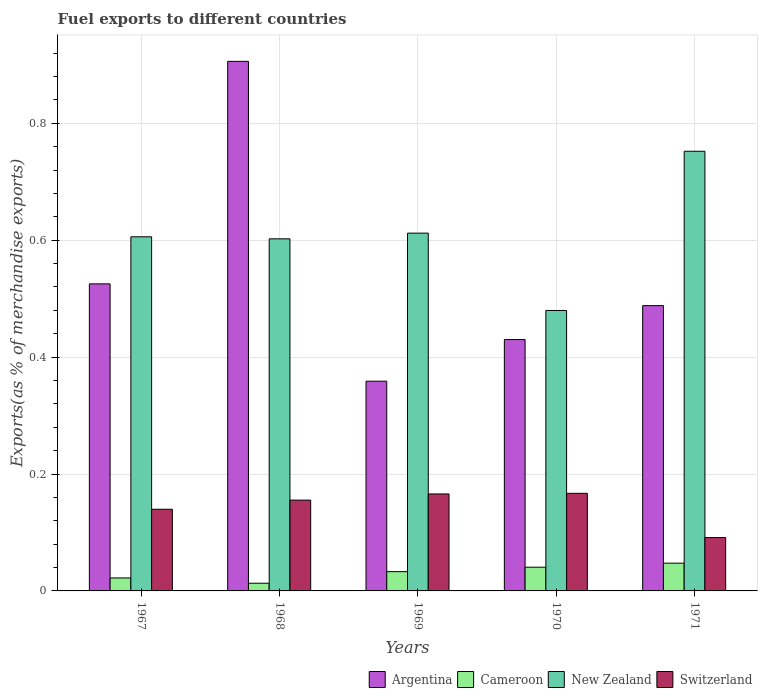How many bars are there on the 1st tick from the left?
Offer a very short reply. 4. What is the label of the 5th group of bars from the left?
Make the answer very short. 1971. What is the percentage of exports to different countries in New Zealand in 1967?
Your response must be concise. 0.61. Across all years, what is the maximum percentage of exports to different countries in Argentina?
Keep it short and to the point. 0.91. Across all years, what is the minimum percentage of exports to different countries in Cameroon?
Offer a very short reply. 0.01. What is the total percentage of exports to different countries in Cameroon in the graph?
Ensure brevity in your answer.  0.16. What is the difference between the percentage of exports to different countries in New Zealand in 1967 and that in 1971?
Offer a terse response. -0.15. What is the difference between the percentage of exports to different countries in Argentina in 1969 and the percentage of exports to different countries in Cameroon in 1970?
Your answer should be compact. 0.32. What is the average percentage of exports to different countries in Switzerland per year?
Offer a terse response. 0.14. In the year 1967, what is the difference between the percentage of exports to different countries in Argentina and percentage of exports to different countries in New Zealand?
Provide a short and direct response. -0.08. What is the ratio of the percentage of exports to different countries in Argentina in 1968 to that in 1971?
Make the answer very short. 1.86. What is the difference between the highest and the second highest percentage of exports to different countries in Switzerland?
Your answer should be compact. 0. What is the difference between the highest and the lowest percentage of exports to different countries in New Zealand?
Give a very brief answer. 0.27. In how many years, is the percentage of exports to different countries in Switzerland greater than the average percentage of exports to different countries in Switzerland taken over all years?
Your response must be concise. 3. Is the sum of the percentage of exports to different countries in Argentina in 1967 and 1968 greater than the maximum percentage of exports to different countries in New Zealand across all years?
Provide a succinct answer. Yes. What does the 2nd bar from the left in 1967 represents?
Give a very brief answer. Cameroon. What does the 2nd bar from the right in 1969 represents?
Your answer should be very brief. New Zealand. Are all the bars in the graph horizontal?
Your answer should be compact. No. What is the difference between two consecutive major ticks on the Y-axis?
Provide a succinct answer. 0.2. Are the values on the major ticks of Y-axis written in scientific E-notation?
Provide a short and direct response. No. Does the graph contain any zero values?
Provide a short and direct response. No. What is the title of the graph?
Your answer should be very brief. Fuel exports to different countries. Does "Cambodia" appear as one of the legend labels in the graph?
Ensure brevity in your answer.  No. What is the label or title of the Y-axis?
Offer a terse response. Exports(as % of merchandise exports). What is the Exports(as % of merchandise exports) of Argentina in 1967?
Offer a terse response. 0.53. What is the Exports(as % of merchandise exports) of Cameroon in 1967?
Provide a succinct answer. 0.02. What is the Exports(as % of merchandise exports) of New Zealand in 1967?
Your response must be concise. 0.61. What is the Exports(as % of merchandise exports) in Switzerland in 1967?
Give a very brief answer. 0.14. What is the Exports(as % of merchandise exports) in Argentina in 1968?
Keep it short and to the point. 0.91. What is the Exports(as % of merchandise exports) of Cameroon in 1968?
Provide a short and direct response. 0.01. What is the Exports(as % of merchandise exports) of New Zealand in 1968?
Your answer should be compact. 0.6. What is the Exports(as % of merchandise exports) in Switzerland in 1968?
Your answer should be very brief. 0.16. What is the Exports(as % of merchandise exports) of Argentina in 1969?
Provide a short and direct response. 0.36. What is the Exports(as % of merchandise exports) of Cameroon in 1969?
Give a very brief answer. 0.03. What is the Exports(as % of merchandise exports) of New Zealand in 1969?
Offer a terse response. 0.61. What is the Exports(as % of merchandise exports) in Switzerland in 1969?
Offer a very short reply. 0.17. What is the Exports(as % of merchandise exports) in Argentina in 1970?
Your answer should be very brief. 0.43. What is the Exports(as % of merchandise exports) in Cameroon in 1970?
Your response must be concise. 0.04. What is the Exports(as % of merchandise exports) in New Zealand in 1970?
Keep it short and to the point. 0.48. What is the Exports(as % of merchandise exports) in Switzerland in 1970?
Provide a succinct answer. 0.17. What is the Exports(as % of merchandise exports) of Argentina in 1971?
Make the answer very short. 0.49. What is the Exports(as % of merchandise exports) in Cameroon in 1971?
Make the answer very short. 0.05. What is the Exports(as % of merchandise exports) in New Zealand in 1971?
Make the answer very short. 0.75. What is the Exports(as % of merchandise exports) of Switzerland in 1971?
Your answer should be compact. 0.09. Across all years, what is the maximum Exports(as % of merchandise exports) of Argentina?
Keep it short and to the point. 0.91. Across all years, what is the maximum Exports(as % of merchandise exports) in Cameroon?
Your answer should be very brief. 0.05. Across all years, what is the maximum Exports(as % of merchandise exports) of New Zealand?
Offer a terse response. 0.75. Across all years, what is the maximum Exports(as % of merchandise exports) in Switzerland?
Your response must be concise. 0.17. Across all years, what is the minimum Exports(as % of merchandise exports) in Argentina?
Ensure brevity in your answer.  0.36. Across all years, what is the minimum Exports(as % of merchandise exports) of Cameroon?
Offer a terse response. 0.01. Across all years, what is the minimum Exports(as % of merchandise exports) in New Zealand?
Offer a terse response. 0.48. Across all years, what is the minimum Exports(as % of merchandise exports) of Switzerland?
Keep it short and to the point. 0.09. What is the total Exports(as % of merchandise exports) in Argentina in the graph?
Your answer should be very brief. 2.71. What is the total Exports(as % of merchandise exports) in Cameroon in the graph?
Offer a very short reply. 0.16. What is the total Exports(as % of merchandise exports) in New Zealand in the graph?
Make the answer very short. 3.05. What is the total Exports(as % of merchandise exports) of Switzerland in the graph?
Offer a terse response. 0.72. What is the difference between the Exports(as % of merchandise exports) of Argentina in 1967 and that in 1968?
Give a very brief answer. -0.38. What is the difference between the Exports(as % of merchandise exports) in Cameroon in 1967 and that in 1968?
Your answer should be compact. 0.01. What is the difference between the Exports(as % of merchandise exports) of New Zealand in 1967 and that in 1968?
Your answer should be very brief. 0. What is the difference between the Exports(as % of merchandise exports) of Switzerland in 1967 and that in 1968?
Offer a very short reply. -0.02. What is the difference between the Exports(as % of merchandise exports) in Argentina in 1967 and that in 1969?
Make the answer very short. 0.17. What is the difference between the Exports(as % of merchandise exports) of Cameroon in 1967 and that in 1969?
Offer a very short reply. -0.01. What is the difference between the Exports(as % of merchandise exports) of New Zealand in 1967 and that in 1969?
Give a very brief answer. -0.01. What is the difference between the Exports(as % of merchandise exports) of Switzerland in 1967 and that in 1969?
Give a very brief answer. -0.03. What is the difference between the Exports(as % of merchandise exports) of Argentina in 1967 and that in 1970?
Provide a short and direct response. 0.1. What is the difference between the Exports(as % of merchandise exports) in Cameroon in 1967 and that in 1970?
Keep it short and to the point. -0.02. What is the difference between the Exports(as % of merchandise exports) in New Zealand in 1967 and that in 1970?
Offer a very short reply. 0.13. What is the difference between the Exports(as % of merchandise exports) of Switzerland in 1967 and that in 1970?
Give a very brief answer. -0.03. What is the difference between the Exports(as % of merchandise exports) in Argentina in 1967 and that in 1971?
Your answer should be very brief. 0.04. What is the difference between the Exports(as % of merchandise exports) in Cameroon in 1967 and that in 1971?
Make the answer very short. -0.03. What is the difference between the Exports(as % of merchandise exports) in New Zealand in 1967 and that in 1971?
Your response must be concise. -0.15. What is the difference between the Exports(as % of merchandise exports) of Switzerland in 1967 and that in 1971?
Offer a terse response. 0.05. What is the difference between the Exports(as % of merchandise exports) in Argentina in 1968 and that in 1969?
Your answer should be compact. 0.55. What is the difference between the Exports(as % of merchandise exports) in Cameroon in 1968 and that in 1969?
Your response must be concise. -0.02. What is the difference between the Exports(as % of merchandise exports) in New Zealand in 1968 and that in 1969?
Give a very brief answer. -0.01. What is the difference between the Exports(as % of merchandise exports) of Switzerland in 1968 and that in 1969?
Give a very brief answer. -0.01. What is the difference between the Exports(as % of merchandise exports) of Argentina in 1968 and that in 1970?
Keep it short and to the point. 0.48. What is the difference between the Exports(as % of merchandise exports) in Cameroon in 1968 and that in 1970?
Keep it short and to the point. -0.03. What is the difference between the Exports(as % of merchandise exports) in New Zealand in 1968 and that in 1970?
Provide a succinct answer. 0.12. What is the difference between the Exports(as % of merchandise exports) of Switzerland in 1968 and that in 1970?
Give a very brief answer. -0.01. What is the difference between the Exports(as % of merchandise exports) of Argentina in 1968 and that in 1971?
Your answer should be compact. 0.42. What is the difference between the Exports(as % of merchandise exports) of Cameroon in 1968 and that in 1971?
Keep it short and to the point. -0.03. What is the difference between the Exports(as % of merchandise exports) in New Zealand in 1968 and that in 1971?
Keep it short and to the point. -0.15. What is the difference between the Exports(as % of merchandise exports) of Switzerland in 1968 and that in 1971?
Your answer should be compact. 0.06. What is the difference between the Exports(as % of merchandise exports) of Argentina in 1969 and that in 1970?
Make the answer very short. -0.07. What is the difference between the Exports(as % of merchandise exports) of Cameroon in 1969 and that in 1970?
Your answer should be very brief. -0.01. What is the difference between the Exports(as % of merchandise exports) of New Zealand in 1969 and that in 1970?
Give a very brief answer. 0.13. What is the difference between the Exports(as % of merchandise exports) of Switzerland in 1969 and that in 1970?
Your response must be concise. -0. What is the difference between the Exports(as % of merchandise exports) in Argentina in 1969 and that in 1971?
Your answer should be compact. -0.13. What is the difference between the Exports(as % of merchandise exports) in Cameroon in 1969 and that in 1971?
Ensure brevity in your answer.  -0.01. What is the difference between the Exports(as % of merchandise exports) of New Zealand in 1969 and that in 1971?
Your answer should be compact. -0.14. What is the difference between the Exports(as % of merchandise exports) in Switzerland in 1969 and that in 1971?
Your answer should be compact. 0.07. What is the difference between the Exports(as % of merchandise exports) in Argentina in 1970 and that in 1971?
Give a very brief answer. -0.06. What is the difference between the Exports(as % of merchandise exports) in Cameroon in 1970 and that in 1971?
Your answer should be compact. -0.01. What is the difference between the Exports(as % of merchandise exports) in New Zealand in 1970 and that in 1971?
Your answer should be very brief. -0.27. What is the difference between the Exports(as % of merchandise exports) of Switzerland in 1970 and that in 1971?
Make the answer very short. 0.08. What is the difference between the Exports(as % of merchandise exports) in Argentina in 1967 and the Exports(as % of merchandise exports) in Cameroon in 1968?
Offer a very short reply. 0.51. What is the difference between the Exports(as % of merchandise exports) of Argentina in 1967 and the Exports(as % of merchandise exports) of New Zealand in 1968?
Make the answer very short. -0.08. What is the difference between the Exports(as % of merchandise exports) in Argentina in 1967 and the Exports(as % of merchandise exports) in Switzerland in 1968?
Make the answer very short. 0.37. What is the difference between the Exports(as % of merchandise exports) in Cameroon in 1967 and the Exports(as % of merchandise exports) in New Zealand in 1968?
Your answer should be compact. -0.58. What is the difference between the Exports(as % of merchandise exports) in Cameroon in 1967 and the Exports(as % of merchandise exports) in Switzerland in 1968?
Ensure brevity in your answer.  -0.13. What is the difference between the Exports(as % of merchandise exports) in New Zealand in 1967 and the Exports(as % of merchandise exports) in Switzerland in 1968?
Keep it short and to the point. 0.45. What is the difference between the Exports(as % of merchandise exports) in Argentina in 1967 and the Exports(as % of merchandise exports) in Cameroon in 1969?
Your answer should be compact. 0.49. What is the difference between the Exports(as % of merchandise exports) of Argentina in 1967 and the Exports(as % of merchandise exports) of New Zealand in 1969?
Keep it short and to the point. -0.09. What is the difference between the Exports(as % of merchandise exports) in Argentina in 1967 and the Exports(as % of merchandise exports) in Switzerland in 1969?
Provide a short and direct response. 0.36. What is the difference between the Exports(as % of merchandise exports) of Cameroon in 1967 and the Exports(as % of merchandise exports) of New Zealand in 1969?
Keep it short and to the point. -0.59. What is the difference between the Exports(as % of merchandise exports) of Cameroon in 1967 and the Exports(as % of merchandise exports) of Switzerland in 1969?
Offer a very short reply. -0.14. What is the difference between the Exports(as % of merchandise exports) of New Zealand in 1967 and the Exports(as % of merchandise exports) of Switzerland in 1969?
Provide a succinct answer. 0.44. What is the difference between the Exports(as % of merchandise exports) of Argentina in 1967 and the Exports(as % of merchandise exports) of Cameroon in 1970?
Your answer should be compact. 0.48. What is the difference between the Exports(as % of merchandise exports) of Argentina in 1967 and the Exports(as % of merchandise exports) of New Zealand in 1970?
Provide a succinct answer. 0.05. What is the difference between the Exports(as % of merchandise exports) in Argentina in 1967 and the Exports(as % of merchandise exports) in Switzerland in 1970?
Make the answer very short. 0.36. What is the difference between the Exports(as % of merchandise exports) in Cameroon in 1967 and the Exports(as % of merchandise exports) in New Zealand in 1970?
Provide a succinct answer. -0.46. What is the difference between the Exports(as % of merchandise exports) in Cameroon in 1967 and the Exports(as % of merchandise exports) in Switzerland in 1970?
Your answer should be compact. -0.14. What is the difference between the Exports(as % of merchandise exports) in New Zealand in 1967 and the Exports(as % of merchandise exports) in Switzerland in 1970?
Your response must be concise. 0.44. What is the difference between the Exports(as % of merchandise exports) of Argentina in 1967 and the Exports(as % of merchandise exports) of Cameroon in 1971?
Make the answer very short. 0.48. What is the difference between the Exports(as % of merchandise exports) in Argentina in 1967 and the Exports(as % of merchandise exports) in New Zealand in 1971?
Your response must be concise. -0.23. What is the difference between the Exports(as % of merchandise exports) of Argentina in 1967 and the Exports(as % of merchandise exports) of Switzerland in 1971?
Offer a terse response. 0.43. What is the difference between the Exports(as % of merchandise exports) of Cameroon in 1967 and the Exports(as % of merchandise exports) of New Zealand in 1971?
Give a very brief answer. -0.73. What is the difference between the Exports(as % of merchandise exports) of Cameroon in 1967 and the Exports(as % of merchandise exports) of Switzerland in 1971?
Make the answer very short. -0.07. What is the difference between the Exports(as % of merchandise exports) in New Zealand in 1967 and the Exports(as % of merchandise exports) in Switzerland in 1971?
Keep it short and to the point. 0.51. What is the difference between the Exports(as % of merchandise exports) in Argentina in 1968 and the Exports(as % of merchandise exports) in Cameroon in 1969?
Give a very brief answer. 0.87. What is the difference between the Exports(as % of merchandise exports) of Argentina in 1968 and the Exports(as % of merchandise exports) of New Zealand in 1969?
Keep it short and to the point. 0.29. What is the difference between the Exports(as % of merchandise exports) in Argentina in 1968 and the Exports(as % of merchandise exports) in Switzerland in 1969?
Your answer should be very brief. 0.74. What is the difference between the Exports(as % of merchandise exports) of Cameroon in 1968 and the Exports(as % of merchandise exports) of New Zealand in 1969?
Your response must be concise. -0.6. What is the difference between the Exports(as % of merchandise exports) of Cameroon in 1968 and the Exports(as % of merchandise exports) of Switzerland in 1969?
Your answer should be very brief. -0.15. What is the difference between the Exports(as % of merchandise exports) in New Zealand in 1968 and the Exports(as % of merchandise exports) in Switzerland in 1969?
Provide a succinct answer. 0.44. What is the difference between the Exports(as % of merchandise exports) in Argentina in 1968 and the Exports(as % of merchandise exports) in Cameroon in 1970?
Provide a short and direct response. 0.87. What is the difference between the Exports(as % of merchandise exports) in Argentina in 1968 and the Exports(as % of merchandise exports) in New Zealand in 1970?
Offer a very short reply. 0.43. What is the difference between the Exports(as % of merchandise exports) in Argentina in 1968 and the Exports(as % of merchandise exports) in Switzerland in 1970?
Ensure brevity in your answer.  0.74. What is the difference between the Exports(as % of merchandise exports) in Cameroon in 1968 and the Exports(as % of merchandise exports) in New Zealand in 1970?
Keep it short and to the point. -0.47. What is the difference between the Exports(as % of merchandise exports) of Cameroon in 1968 and the Exports(as % of merchandise exports) of Switzerland in 1970?
Keep it short and to the point. -0.15. What is the difference between the Exports(as % of merchandise exports) of New Zealand in 1968 and the Exports(as % of merchandise exports) of Switzerland in 1970?
Provide a short and direct response. 0.44. What is the difference between the Exports(as % of merchandise exports) in Argentina in 1968 and the Exports(as % of merchandise exports) in Cameroon in 1971?
Provide a short and direct response. 0.86. What is the difference between the Exports(as % of merchandise exports) of Argentina in 1968 and the Exports(as % of merchandise exports) of New Zealand in 1971?
Your response must be concise. 0.15. What is the difference between the Exports(as % of merchandise exports) in Argentina in 1968 and the Exports(as % of merchandise exports) in Switzerland in 1971?
Your answer should be very brief. 0.81. What is the difference between the Exports(as % of merchandise exports) in Cameroon in 1968 and the Exports(as % of merchandise exports) in New Zealand in 1971?
Offer a terse response. -0.74. What is the difference between the Exports(as % of merchandise exports) in Cameroon in 1968 and the Exports(as % of merchandise exports) in Switzerland in 1971?
Your answer should be very brief. -0.08. What is the difference between the Exports(as % of merchandise exports) in New Zealand in 1968 and the Exports(as % of merchandise exports) in Switzerland in 1971?
Give a very brief answer. 0.51. What is the difference between the Exports(as % of merchandise exports) in Argentina in 1969 and the Exports(as % of merchandise exports) in Cameroon in 1970?
Ensure brevity in your answer.  0.32. What is the difference between the Exports(as % of merchandise exports) of Argentina in 1969 and the Exports(as % of merchandise exports) of New Zealand in 1970?
Make the answer very short. -0.12. What is the difference between the Exports(as % of merchandise exports) of Argentina in 1969 and the Exports(as % of merchandise exports) of Switzerland in 1970?
Offer a terse response. 0.19. What is the difference between the Exports(as % of merchandise exports) in Cameroon in 1969 and the Exports(as % of merchandise exports) in New Zealand in 1970?
Your answer should be very brief. -0.45. What is the difference between the Exports(as % of merchandise exports) in Cameroon in 1969 and the Exports(as % of merchandise exports) in Switzerland in 1970?
Offer a very short reply. -0.13. What is the difference between the Exports(as % of merchandise exports) in New Zealand in 1969 and the Exports(as % of merchandise exports) in Switzerland in 1970?
Keep it short and to the point. 0.45. What is the difference between the Exports(as % of merchandise exports) in Argentina in 1969 and the Exports(as % of merchandise exports) in Cameroon in 1971?
Ensure brevity in your answer.  0.31. What is the difference between the Exports(as % of merchandise exports) in Argentina in 1969 and the Exports(as % of merchandise exports) in New Zealand in 1971?
Provide a short and direct response. -0.39. What is the difference between the Exports(as % of merchandise exports) of Argentina in 1969 and the Exports(as % of merchandise exports) of Switzerland in 1971?
Make the answer very short. 0.27. What is the difference between the Exports(as % of merchandise exports) of Cameroon in 1969 and the Exports(as % of merchandise exports) of New Zealand in 1971?
Provide a short and direct response. -0.72. What is the difference between the Exports(as % of merchandise exports) in Cameroon in 1969 and the Exports(as % of merchandise exports) in Switzerland in 1971?
Offer a terse response. -0.06. What is the difference between the Exports(as % of merchandise exports) in New Zealand in 1969 and the Exports(as % of merchandise exports) in Switzerland in 1971?
Offer a terse response. 0.52. What is the difference between the Exports(as % of merchandise exports) in Argentina in 1970 and the Exports(as % of merchandise exports) in Cameroon in 1971?
Provide a succinct answer. 0.38. What is the difference between the Exports(as % of merchandise exports) in Argentina in 1970 and the Exports(as % of merchandise exports) in New Zealand in 1971?
Your answer should be very brief. -0.32. What is the difference between the Exports(as % of merchandise exports) in Argentina in 1970 and the Exports(as % of merchandise exports) in Switzerland in 1971?
Your answer should be compact. 0.34. What is the difference between the Exports(as % of merchandise exports) of Cameroon in 1970 and the Exports(as % of merchandise exports) of New Zealand in 1971?
Give a very brief answer. -0.71. What is the difference between the Exports(as % of merchandise exports) in Cameroon in 1970 and the Exports(as % of merchandise exports) in Switzerland in 1971?
Keep it short and to the point. -0.05. What is the difference between the Exports(as % of merchandise exports) in New Zealand in 1970 and the Exports(as % of merchandise exports) in Switzerland in 1971?
Ensure brevity in your answer.  0.39. What is the average Exports(as % of merchandise exports) in Argentina per year?
Offer a terse response. 0.54. What is the average Exports(as % of merchandise exports) of Cameroon per year?
Provide a succinct answer. 0.03. What is the average Exports(as % of merchandise exports) in New Zealand per year?
Offer a very short reply. 0.61. What is the average Exports(as % of merchandise exports) in Switzerland per year?
Your answer should be very brief. 0.14. In the year 1967, what is the difference between the Exports(as % of merchandise exports) in Argentina and Exports(as % of merchandise exports) in Cameroon?
Keep it short and to the point. 0.5. In the year 1967, what is the difference between the Exports(as % of merchandise exports) in Argentina and Exports(as % of merchandise exports) in New Zealand?
Your response must be concise. -0.08. In the year 1967, what is the difference between the Exports(as % of merchandise exports) in Argentina and Exports(as % of merchandise exports) in Switzerland?
Keep it short and to the point. 0.39. In the year 1967, what is the difference between the Exports(as % of merchandise exports) of Cameroon and Exports(as % of merchandise exports) of New Zealand?
Your answer should be very brief. -0.58. In the year 1967, what is the difference between the Exports(as % of merchandise exports) of Cameroon and Exports(as % of merchandise exports) of Switzerland?
Give a very brief answer. -0.12. In the year 1967, what is the difference between the Exports(as % of merchandise exports) of New Zealand and Exports(as % of merchandise exports) of Switzerland?
Your response must be concise. 0.47. In the year 1968, what is the difference between the Exports(as % of merchandise exports) of Argentina and Exports(as % of merchandise exports) of Cameroon?
Your answer should be very brief. 0.89. In the year 1968, what is the difference between the Exports(as % of merchandise exports) of Argentina and Exports(as % of merchandise exports) of New Zealand?
Provide a short and direct response. 0.3. In the year 1968, what is the difference between the Exports(as % of merchandise exports) in Argentina and Exports(as % of merchandise exports) in Switzerland?
Your response must be concise. 0.75. In the year 1968, what is the difference between the Exports(as % of merchandise exports) of Cameroon and Exports(as % of merchandise exports) of New Zealand?
Make the answer very short. -0.59. In the year 1968, what is the difference between the Exports(as % of merchandise exports) in Cameroon and Exports(as % of merchandise exports) in Switzerland?
Offer a very short reply. -0.14. In the year 1968, what is the difference between the Exports(as % of merchandise exports) of New Zealand and Exports(as % of merchandise exports) of Switzerland?
Give a very brief answer. 0.45. In the year 1969, what is the difference between the Exports(as % of merchandise exports) of Argentina and Exports(as % of merchandise exports) of Cameroon?
Give a very brief answer. 0.33. In the year 1969, what is the difference between the Exports(as % of merchandise exports) in Argentina and Exports(as % of merchandise exports) in New Zealand?
Your answer should be very brief. -0.25. In the year 1969, what is the difference between the Exports(as % of merchandise exports) in Argentina and Exports(as % of merchandise exports) in Switzerland?
Your response must be concise. 0.19. In the year 1969, what is the difference between the Exports(as % of merchandise exports) in Cameroon and Exports(as % of merchandise exports) in New Zealand?
Your answer should be very brief. -0.58. In the year 1969, what is the difference between the Exports(as % of merchandise exports) in Cameroon and Exports(as % of merchandise exports) in Switzerland?
Provide a succinct answer. -0.13. In the year 1969, what is the difference between the Exports(as % of merchandise exports) of New Zealand and Exports(as % of merchandise exports) of Switzerland?
Make the answer very short. 0.45. In the year 1970, what is the difference between the Exports(as % of merchandise exports) in Argentina and Exports(as % of merchandise exports) in Cameroon?
Your answer should be very brief. 0.39. In the year 1970, what is the difference between the Exports(as % of merchandise exports) of Argentina and Exports(as % of merchandise exports) of New Zealand?
Your answer should be very brief. -0.05. In the year 1970, what is the difference between the Exports(as % of merchandise exports) of Argentina and Exports(as % of merchandise exports) of Switzerland?
Ensure brevity in your answer.  0.26. In the year 1970, what is the difference between the Exports(as % of merchandise exports) in Cameroon and Exports(as % of merchandise exports) in New Zealand?
Your response must be concise. -0.44. In the year 1970, what is the difference between the Exports(as % of merchandise exports) in Cameroon and Exports(as % of merchandise exports) in Switzerland?
Give a very brief answer. -0.13. In the year 1970, what is the difference between the Exports(as % of merchandise exports) in New Zealand and Exports(as % of merchandise exports) in Switzerland?
Your answer should be compact. 0.31. In the year 1971, what is the difference between the Exports(as % of merchandise exports) in Argentina and Exports(as % of merchandise exports) in Cameroon?
Provide a short and direct response. 0.44. In the year 1971, what is the difference between the Exports(as % of merchandise exports) of Argentina and Exports(as % of merchandise exports) of New Zealand?
Provide a succinct answer. -0.26. In the year 1971, what is the difference between the Exports(as % of merchandise exports) of Argentina and Exports(as % of merchandise exports) of Switzerland?
Your response must be concise. 0.4. In the year 1971, what is the difference between the Exports(as % of merchandise exports) of Cameroon and Exports(as % of merchandise exports) of New Zealand?
Give a very brief answer. -0.7. In the year 1971, what is the difference between the Exports(as % of merchandise exports) of Cameroon and Exports(as % of merchandise exports) of Switzerland?
Make the answer very short. -0.04. In the year 1971, what is the difference between the Exports(as % of merchandise exports) of New Zealand and Exports(as % of merchandise exports) of Switzerland?
Your answer should be compact. 0.66. What is the ratio of the Exports(as % of merchandise exports) in Argentina in 1967 to that in 1968?
Provide a succinct answer. 0.58. What is the ratio of the Exports(as % of merchandise exports) in Cameroon in 1967 to that in 1968?
Give a very brief answer. 1.69. What is the ratio of the Exports(as % of merchandise exports) in Switzerland in 1967 to that in 1968?
Ensure brevity in your answer.  0.9. What is the ratio of the Exports(as % of merchandise exports) of Argentina in 1967 to that in 1969?
Your response must be concise. 1.46. What is the ratio of the Exports(as % of merchandise exports) of Cameroon in 1967 to that in 1969?
Keep it short and to the point. 0.67. What is the ratio of the Exports(as % of merchandise exports) of Switzerland in 1967 to that in 1969?
Your response must be concise. 0.84. What is the ratio of the Exports(as % of merchandise exports) in Argentina in 1967 to that in 1970?
Your answer should be very brief. 1.22. What is the ratio of the Exports(as % of merchandise exports) in Cameroon in 1967 to that in 1970?
Provide a succinct answer. 0.55. What is the ratio of the Exports(as % of merchandise exports) in New Zealand in 1967 to that in 1970?
Provide a short and direct response. 1.26. What is the ratio of the Exports(as % of merchandise exports) in Switzerland in 1967 to that in 1970?
Your answer should be very brief. 0.84. What is the ratio of the Exports(as % of merchandise exports) of Argentina in 1967 to that in 1971?
Your answer should be very brief. 1.08. What is the ratio of the Exports(as % of merchandise exports) of Cameroon in 1967 to that in 1971?
Ensure brevity in your answer.  0.47. What is the ratio of the Exports(as % of merchandise exports) in New Zealand in 1967 to that in 1971?
Provide a succinct answer. 0.81. What is the ratio of the Exports(as % of merchandise exports) in Switzerland in 1967 to that in 1971?
Provide a short and direct response. 1.53. What is the ratio of the Exports(as % of merchandise exports) of Argentina in 1968 to that in 1969?
Provide a succinct answer. 2.52. What is the ratio of the Exports(as % of merchandise exports) of Cameroon in 1968 to that in 1969?
Your response must be concise. 0.4. What is the ratio of the Exports(as % of merchandise exports) in New Zealand in 1968 to that in 1969?
Your answer should be compact. 0.98. What is the ratio of the Exports(as % of merchandise exports) in Switzerland in 1968 to that in 1969?
Give a very brief answer. 0.94. What is the ratio of the Exports(as % of merchandise exports) in Argentina in 1968 to that in 1970?
Your answer should be very brief. 2.11. What is the ratio of the Exports(as % of merchandise exports) in Cameroon in 1968 to that in 1970?
Your response must be concise. 0.32. What is the ratio of the Exports(as % of merchandise exports) in New Zealand in 1968 to that in 1970?
Keep it short and to the point. 1.26. What is the ratio of the Exports(as % of merchandise exports) of Switzerland in 1968 to that in 1970?
Ensure brevity in your answer.  0.93. What is the ratio of the Exports(as % of merchandise exports) in Argentina in 1968 to that in 1971?
Offer a terse response. 1.86. What is the ratio of the Exports(as % of merchandise exports) of Cameroon in 1968 to that in 1971?
Give a very brief answer. 0.28. What is the ratio of the Exports(as % of merchandise exports) of New Zealand in 1968 to that in 1971?
Keep it short and to the point. 0.8. What is the ratio of the Exports(as % of merchandise exports) in Switzerland in 1968 to that in 1971?
Provide a succinct answer. 1.7. What is the ratio of the Exports(as % of merchandise exports) of Argentina in 1969 to that in 1970?
Ensure brevity in your answer.  0.83. What is the ratio of the Exports(as % of merchandise exports) in Cameroon in 1969 to that in 1970?
Offer a terse response. 0.81. What is the ratio of the Exports(as % of merchandise exports) in New Zealand in 1969 to that in 1970?
Provide a short and direct response. 1.28. What is the ratio of the Exports(as % of merchandise exports) in Switzerland in 1969 to that in 1970?
Keep it short and to the point. 0.99. What is the ratio of the Exports(as % of merchandise exports) of Argentina in 1969 to that in 1971?
Give a very brief answer. 0.74. What is the ratio of the Exports(as % of merchandise exports) in Cameroon in 1969 to that in 1971?
Ensure brevity in your answer.  0.69. What is the ratio of the Exports(as % of merchandise exports) of New Zealand in 1969 to that in 1971?
Your response must be concise. 0.81. What is the ratio of the Exports(as % of merchandise exports) of Switzerland in 1969 to that in 1971?
Offer a very short reply. 1.82. What is the ratio of the Exports(as % of merchandise exports) in Argentina in 1970 to that in 1971?
Provide a succinct answer. 0.88. What is the ratio of the Exports(as % of merchandise exports) of Cameroon in 1970 to that in 1971?
Provide a short and direct response. 0.85. What is the ratio of the Exports(as % of merchandise exports) of New Zealand in 1970 to that in 1971?
Keep it short and to the point. 0.64. What is the ratio of the Exports(as % of merchandise exports) in Switzerland in 1970 to that in 1971?
Keep it short and to the point. 1.83. What is the difference between the highest and the second highest Exports(as % of merchandise exports) of Argentina?
Ensure brevity in your answer.  0.38. What is the difference between the highest and the second highest Exports(as % of merchandise exports) in Cameroon?
Offer a very short reply. 0.01. What is the difference between the highest and the second highest Exports(as % of merchandise exports) of New Zealand?
Provide a succinct answer. 0.14. What is the difference between the highest and the second highest Exports(as % of merchandise exports) in Switzerland?
Your answer should be very brief. 0. What is the difference between the highest and the lowest Exports(as % of merchandise exports) in Argentina?
Ensure brevity in your answer.  0.55. What is the difference between the highest and the lowest Exports(as % of merchandise exports) of Cameroon?
Make the answer very short. 0.03. What is the difference between the highest and the lowest Exports(as % of merchandise exports) of New Zealand?
Provide a succinct answer. 0.27. What is the difference between the highest and the lowest Exports(as % of merchandise exports) of Switzerland?
Your answer should be very brief. 0.08. 